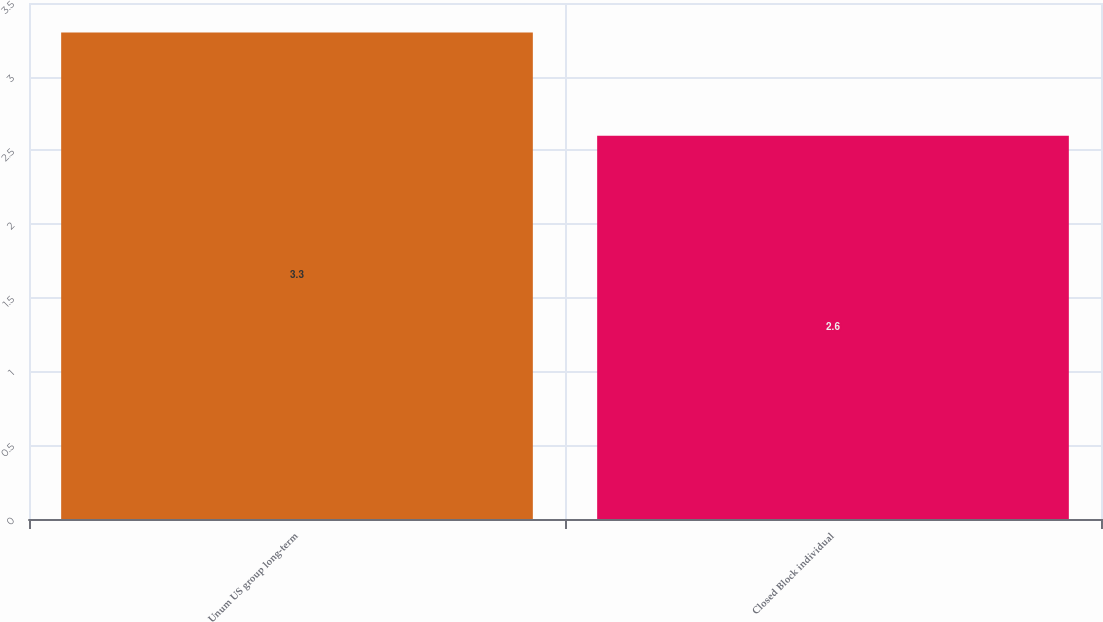Convert chart. <chart><loc_0><loc_0><loc_500><loc_500><bar_chart><fcel>Unum US group long-term<fcel>Closed Block individual<nl><fcel>3.3<fcel>2.6<nl></chart> 